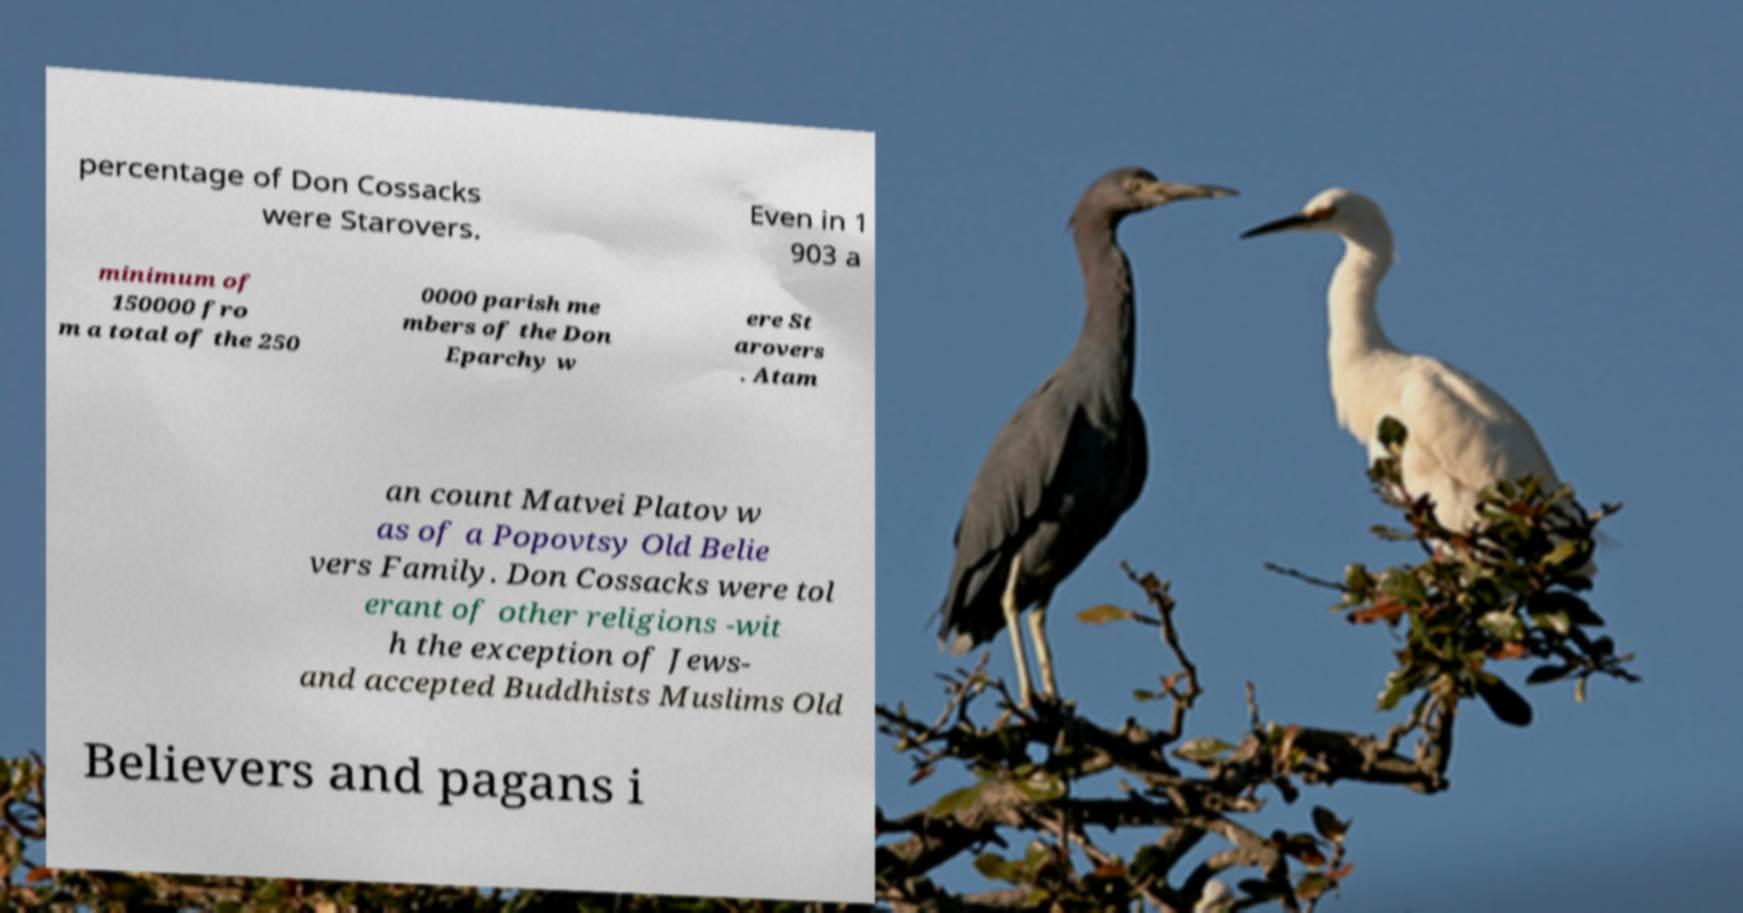Could you assist in decoding the text presented in this image and type it out clearly? percentage of Don Cossacks were Starovers. Even in 1 903 a minimum of 150000 fro m a total of the 250 0000 parish me mbers of the Don Eparchy w ere St arovers . Atam an count Matvei Platov w as of a Popovtsy Old Belie vers Family. Don Cossacks were tol erant of other religions -wit h the exception of Jews- and accepted Buddhists Muslims Old Believers and pagans i 